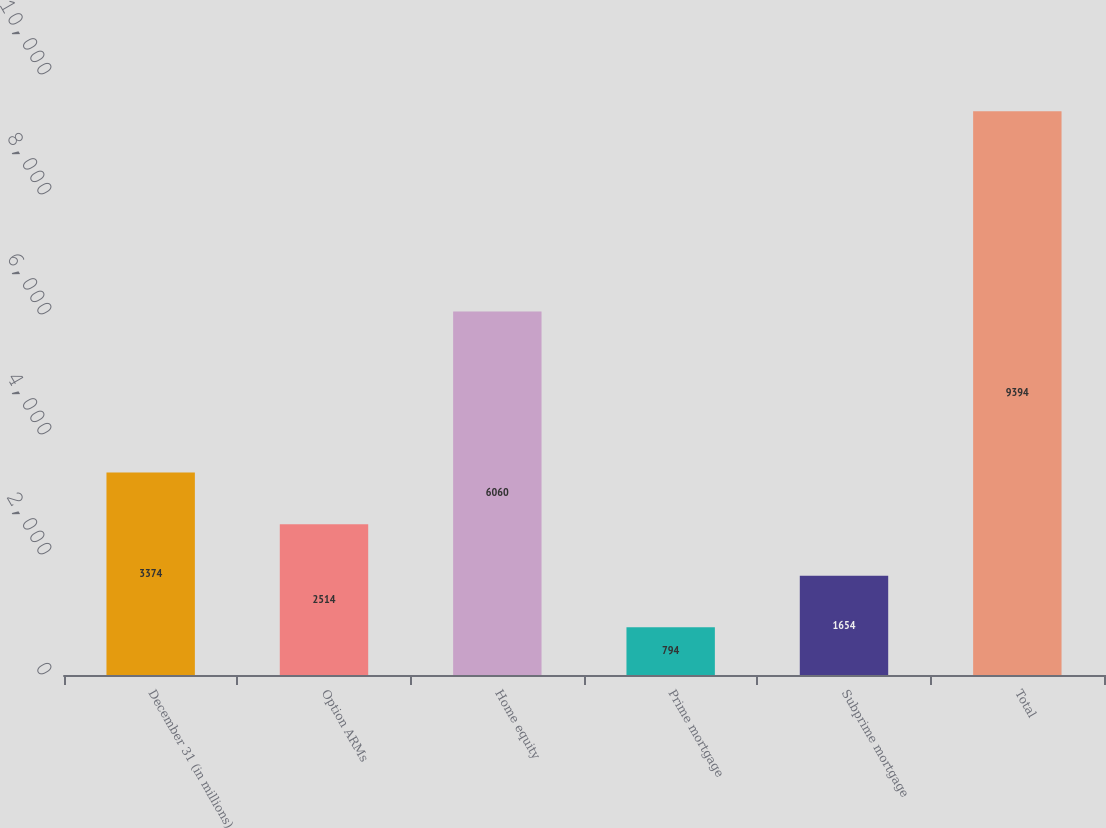Convert chart. <chart><loc_0><loc_0><loc_500><loc_500><bar_chart><fcel>December 31 (in millions)<fcel>Option ARMs<fcel>Home equity<fcel>Prime mortgage<fcel>Subprime mortgage<fcel>Total<nl><fcel>3374<fcel>2514<fcel>6060<fcel>794<fcel>1654<fcel>9394<nl></chart> 